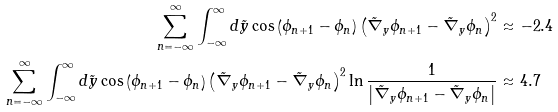<formula> <loc_0><loc_0><loc_500><loc_500>\sum _ { n = - \infty } ^ { \infty } \int _ { - \infty } ^ { \infty } d \tilde { y } \cos \left ( \phi _ { n + 1 } - \phi _ { n } \right ) \left ( \tilde { \nabla } _ { y } \phi _ { n + 1 } - \tilde { \nabla } _ { y } \phi _ { n } \right ) ^ { 2 } & \approx - 2 . 4 \\ \sum _ { n = - \infty } ^ { \infty } \int _ { - \infty } ^ { \infty } d \tilde { y } \cos \left ( \phi _ { n + 1 } - \phi _ { n } \right ) \left ( \tilde { \nabla } _ { y } \phi _ { n + 1 } - \tilde { \nabla } _ { y } \phi _ { n } \right ) ^ { 2 } \ln \frac { 1 } { \left | \tilde { \nabla } _ { y } \phi _ { n + 1 } - \tilde { \nabla } _ { y } \phi _ { n } \right | } & \approx 4 . 7</formula> 